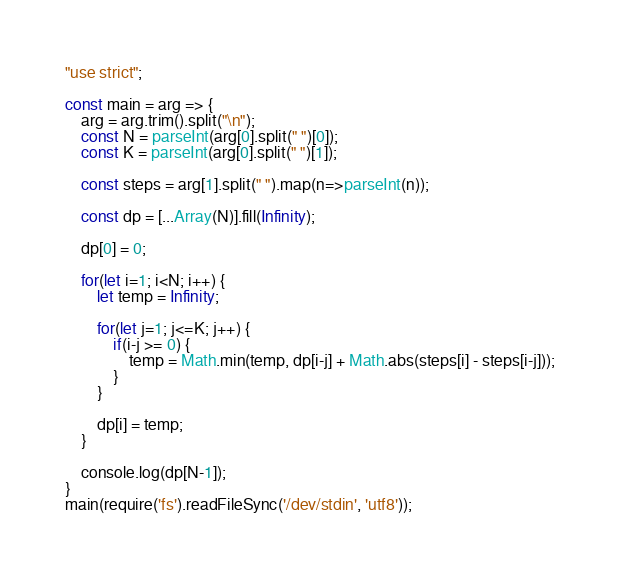Convert code to text. <code><loc_0><loc_0><loc_500><loc_500><_JavaScript_>"use strict";
    
const main = arg => {
    arg = arg.trim().split("\n");
    const N = parseInt(arg[0].split(" ")[0]);
    const K = parseInt(arg[0].split(" ")[1]);
    
    const steps = arg[1].split(" ").map(n=>parseInt(n));
    
    const dp = [...Array(N)].fill(Infinity);
    
    dp[0] = 0;
    
    for(let i=1; i<N; i++) {
        let temp = Infinity;
        
        for(let j=1; j<=K; j++) {
            if(i-j >= 0) {
                temp = Math.min(temp, dp[i-j] + Math.abs(steps[i] - steps[i-j]));
            }
        }
        
        dp[i] = temp;
    }
    
    console.log(dp[N-1]);
}
main(require('fs').readFileSync('/dev/stdin', 'utf8'));</code> 